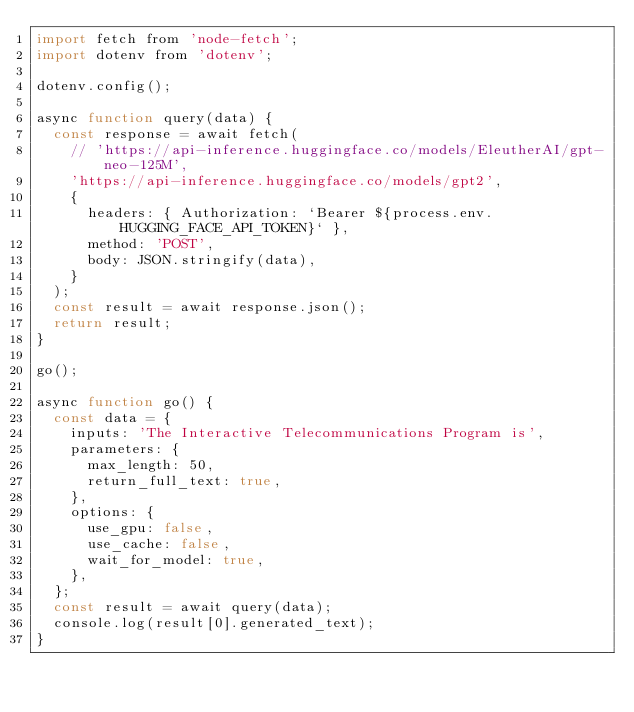Convert code to text. <code><loc_0><loc_0><loc_500><loc_500><_JavaScript_>import fetch from 'node-fetch';
import dotenv from 'dotenv';

dotenv.config();

async function query(data) {
  const response = await fetch(
    // 'https://api-inference.huggingface.co/models/EleutherAI/gpt-neo-125M',
    'https://api-inference.huggingface.co/models/gpt2',
    {
      headers: { Authorization: `Bearer ${process.env.HUGGING_FACE_API_TOKEN}` },
      method: 'POST',
      body: JSON.stringify(data),
    }
  );
  const result = await response.json();
  return result;
}

go();

async function go() {
  const data = {
    inputs: 'The Interactive Telecommunications Program is',
    parameters: {
      max_length: 50,
      return_full_text: true,
    },
    options: {
      use_gpu: false,
      use_cache: false,
      wait_for_model: true,
    },
  };
  const result = await query(data);
  console.log(result[0].generated_text);
}
</code> 